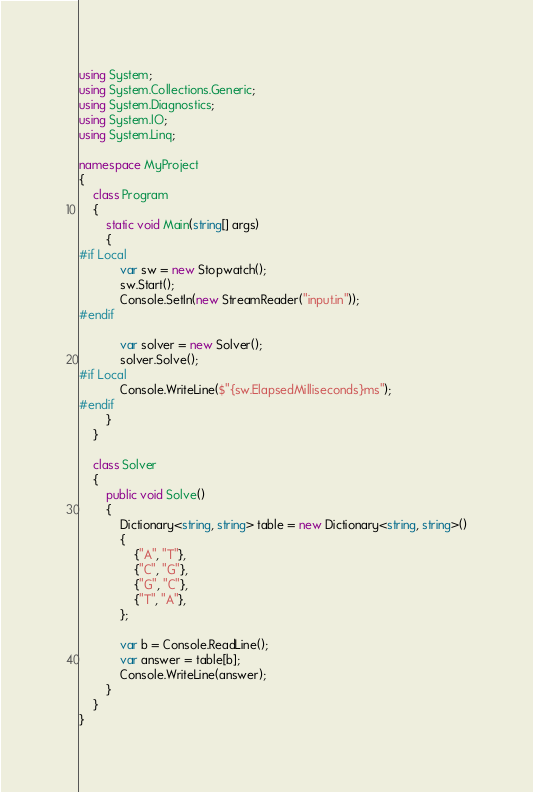Convert code to text. <code><loc_0><loc_0><loc_500><loc_500><_C#_>using System;
using System.Collections.Generic;
using System.Diagnostics;
using System.IO;
using System.Linq;

namespace MyProject
{
    class Program
    {
        static void Main(string[] args)
        {
#if Local
            var sw = new Stopwatch();
            sw.Start();
            Console.SetIn(new StreamReader("input.in"));
#endif

            var solver = new Solver();
            solver.Solve();
#if Local
            Console.WriteLine($"{sw.ElapsedMilliseconds}ms");
#endif
        }
    }

    class Solver
    {
        public void Solve()
        {
            Dictionary<string, string> table = new Dictionary<string, string>()
            {
                {"A", "T"},
                {"C", "G"},
                {"G", "C"},
                {"T", "A"},
            };

            var b = Console.ReadLine();
            var answer = table[b];
            Console.WriteLine(answer);
        }
    }
}
</code> 